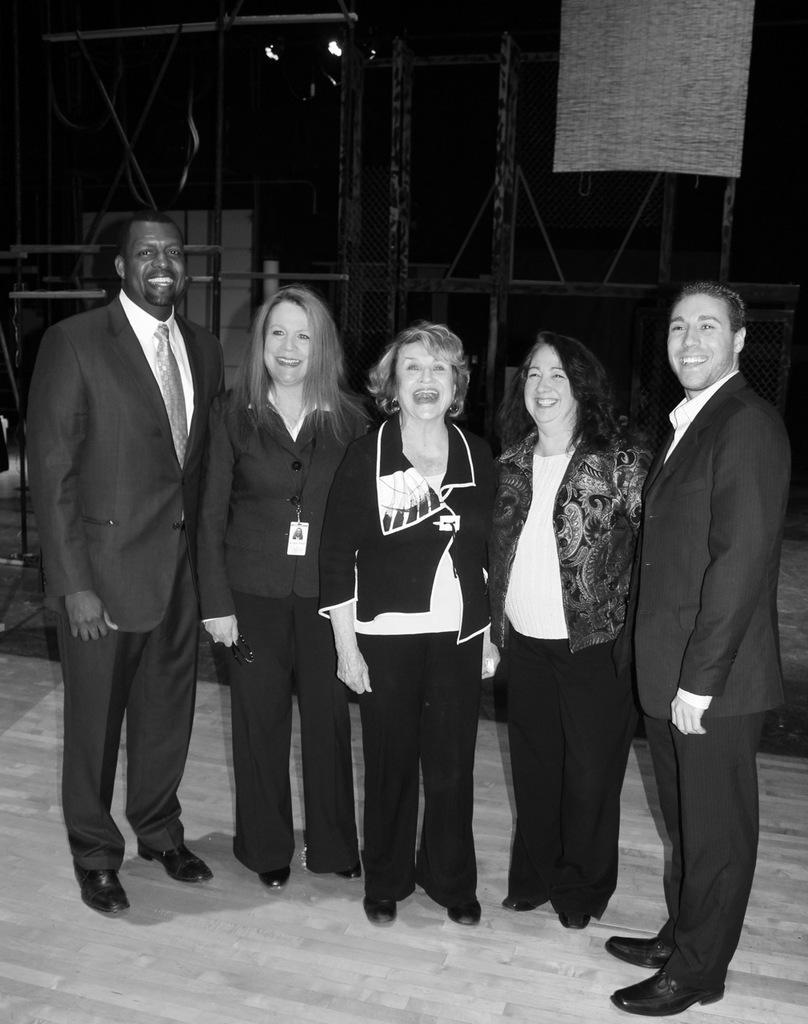Can you describe this image briefly? This picture is black and white image. In the center of the image some persons are standing. In the background of the image we can see mesh, lights, board are there. At the bottom of the image floor is there. 